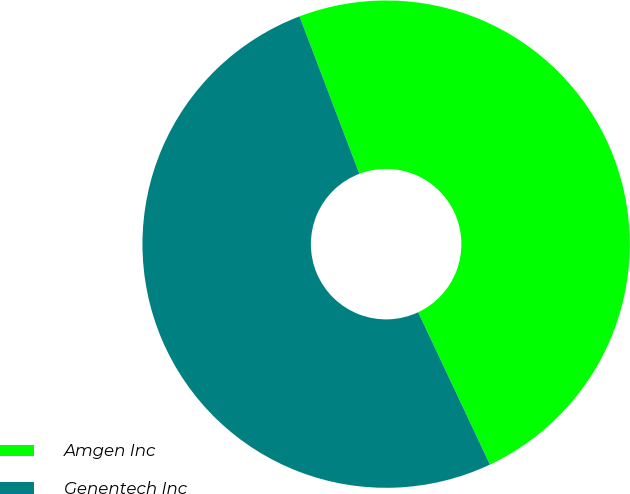Convert chart. <chart><loc_0><loc_0><loc_500><loc_500><pie_chart><fcel>Amgen Inc<fcel>Genentech Inc<nl><fcel>48.78%<fcel>51.22%<nl></chart> 